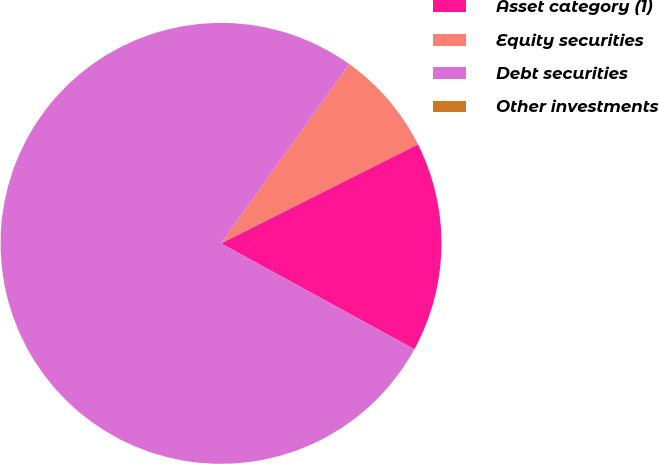Convert chart. <chart><loc_0><loc_0><loc_500><loc_500><pie_chart><fcel>Asset category (1)<fcel>Equity securities<fcel>Debt securities<fcel>Other investments<nl><fcel>15.39%<fcel>7.7%<fcel>76.91%<fcel>0.01%<nl></chart> 